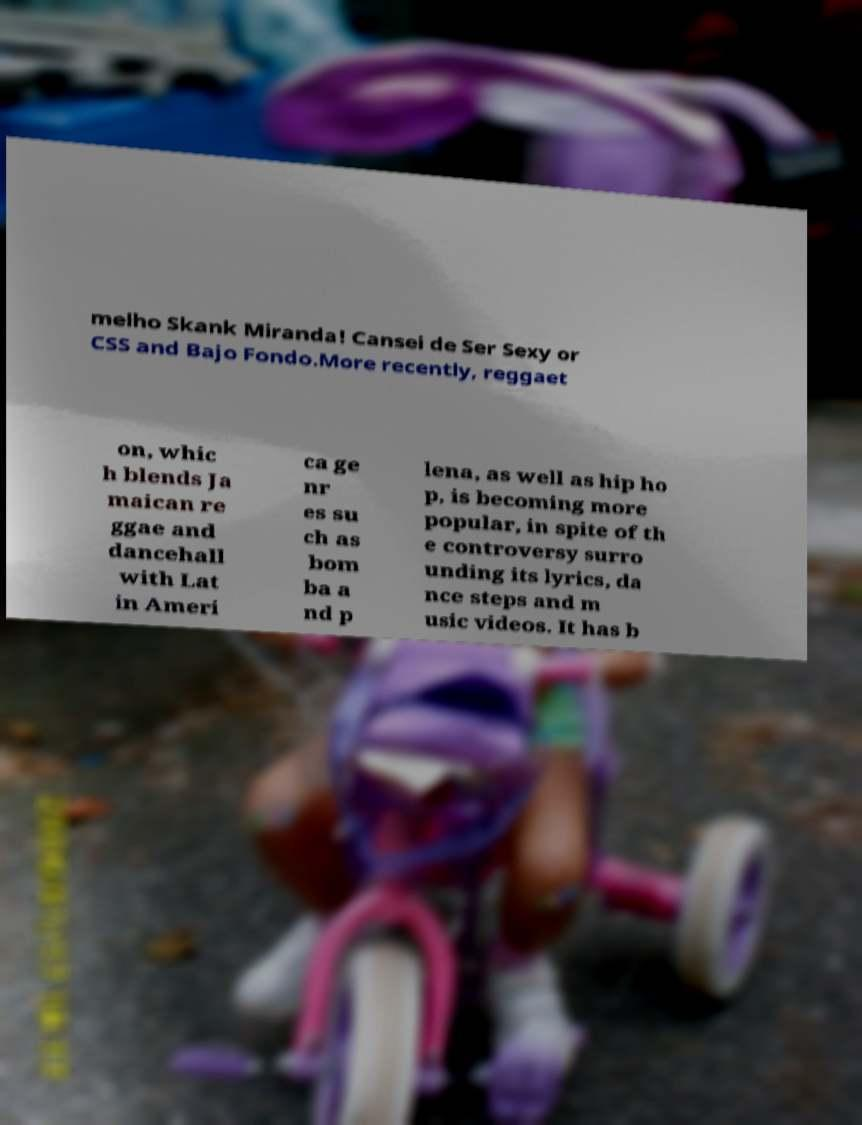Can you read and provide the text displayed in the image?This photo seems to have some interesting text. Can you extract and type it out for me? melho Skank Miranda! Cansei de Ser Sexy or CSS and Bajo Fondo.More recently, reggaet on, whic h blends Ja maican re ggae and dancehall with Lat in Ameri ca ge nr es su ch as bom ba a nd p lena, as well as hip ho p, is becoming more popular, in spite of th e controversy surro unding its lyrics, da nce steps and m usic videos. It has b 